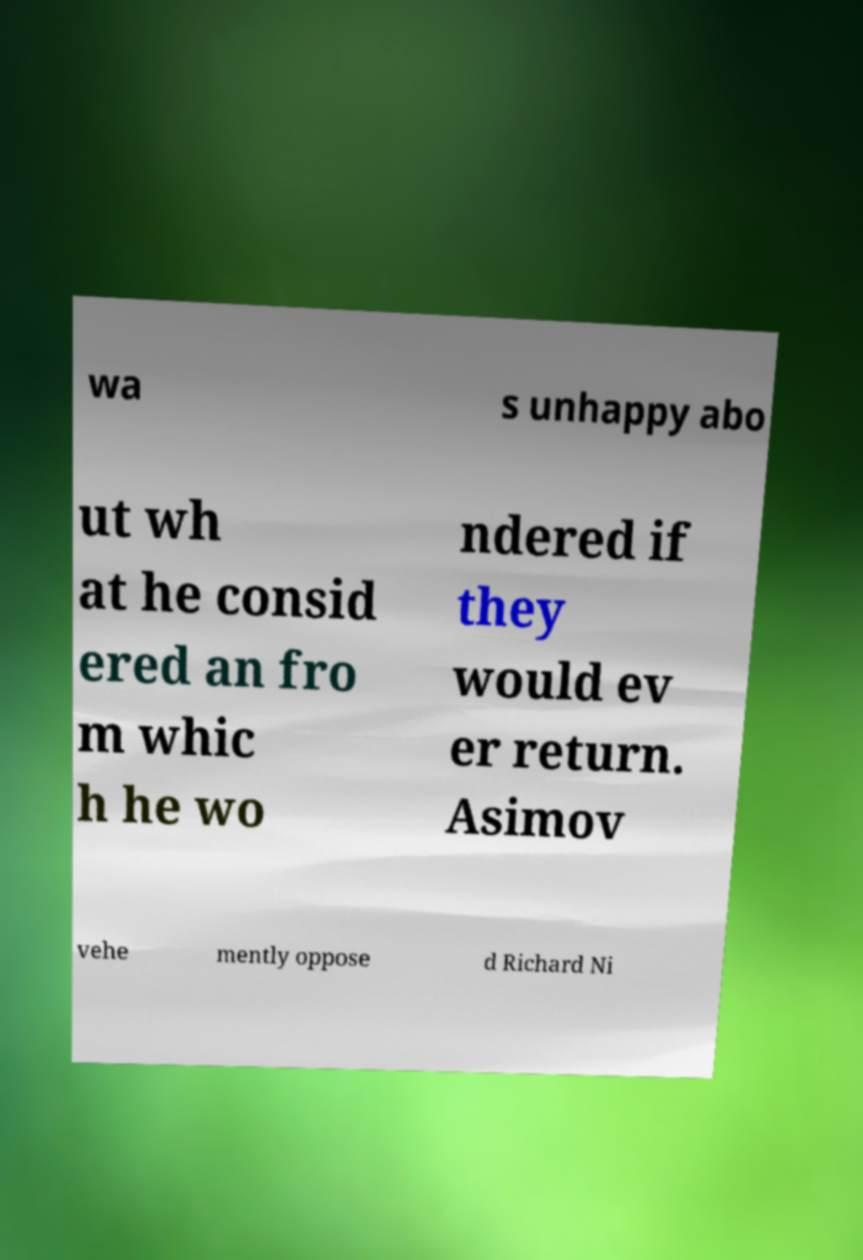What messages or text are displayed in this image? I need them in a readable, typed format. wa s unhappy abo ut wh at he consid ered an fro m whic h he wo ndered if they would ev er return. Asimov vehe mently oppose d Richard Ni 